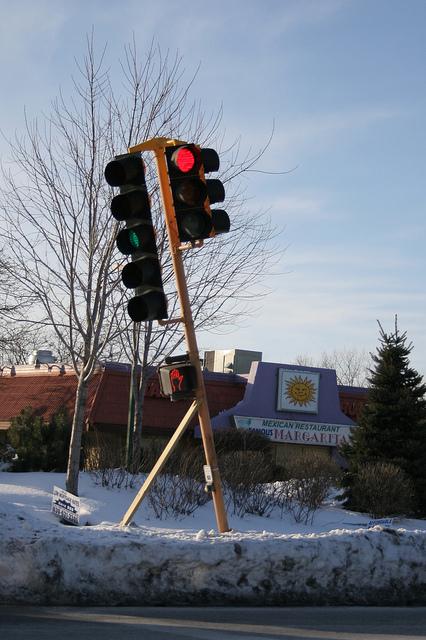What does red mean?
Short answer required. Stop. Is the light going to fall?
Answer briefly. Yes. Is the traffic light standing straight up?
Answer briefly. No. 